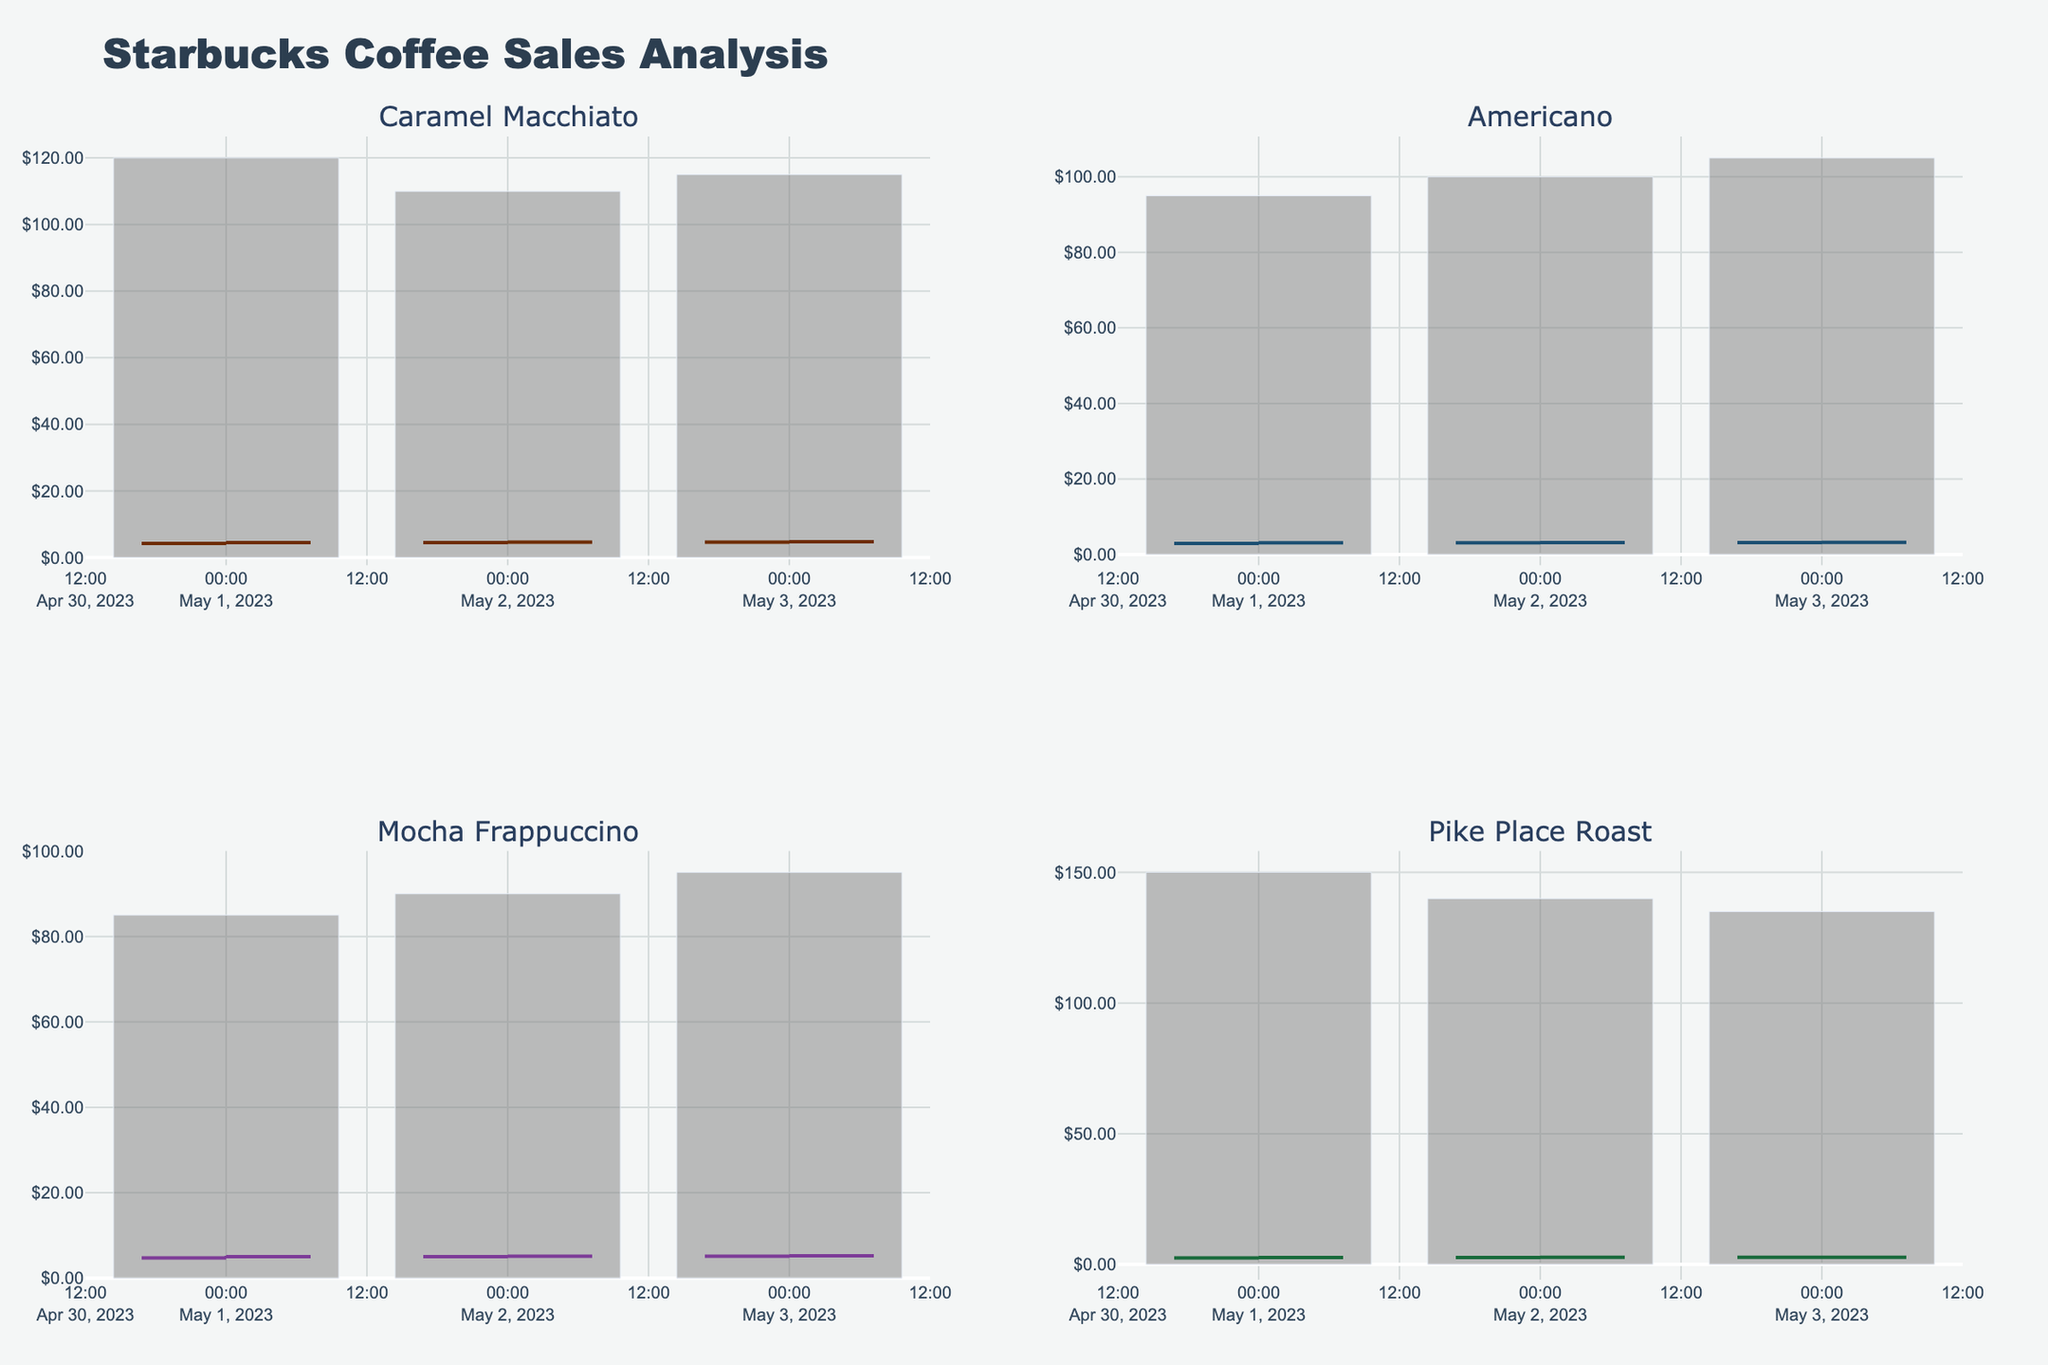What is the title of the figure? The title of the figure is usually displayed at the top and summarizes the content of the chart. For this figure, the title is "Starbucks Coffee Sales Analysis."
Answer: Starbucks Coffee Sales Analysis What are the four drink types represented in the figure? The drink types are usually the categories for which data is displayed. Here, the subplot titles represent the drink types: "Caramel Macchiato," "Americano," "Mocha Frappuccino," and "Pike Place Roast."
Answer: Caramel Macchiato, Americano, Mocha Frappuccino, Pike Place Roast Which drink type had the highest closing price on May 3rd? Look at the "Close" prices for May 3rd for each drink type. The highest closing price on May 3rd is for "Mocha Frappuccino" at $5.25.
Answer: Mocha Frappuccino What was the lowest price recorded for "Pike Place Roast" across all three days? Check the "Low" prices for "Pike Place Roast" across all days. The lowest price recorded is $2.35 on May 1st.
Answer: $2.35 Compare the trading volume for "Americano" and "Caramel Macchiato" on May 2nd. Which drink had higher volume? Look at the "Volume" for both drinks on May 2nd. "Americano" had a volume of 100, while "Caramel Macchiato" had a volume of 110, so "Caramel Macchiato" had the higher volume.
Answer: Caramel Macchiato Which drink showed the most consistent increase in closing price over the three days? Calculate the change in closing price day by day for each drink. "Caramel Macchiato" had closing prices of 4.50, 4.65, and 4.75, each of which is higher than the previous day's. This indicates a consistent increase.
Answer: Caramel Macchiato What is the average high price for "Mocha Frappuccino" over the three days? Add up the "High" prices for "Mocha Frappuccino" (5.25, 5.35, 5.40) and divide by 3. The sum is 15.00, and the average is 15.00/3 = 5.00.
Answer: $5.00 Which day had the highest total trading volume for all drinks combined? Add up the "Volume" for all drinks on each day. May 1st has a total volume of 450, May 2nd has 440, and May 3rd has 450. Hence, May 1st and May 3rd both had the highest total trading volume.
Answer: May 1st and May 3rd What is the difference between the highest and lowest closing prices for "Americano" across all three days? Find the highest closing price (3.20) and the lowest closing price (3.10) for "Americano" and calculate their difference: 3.20 - 3.10 = 0.10.
Answer: $0.10 